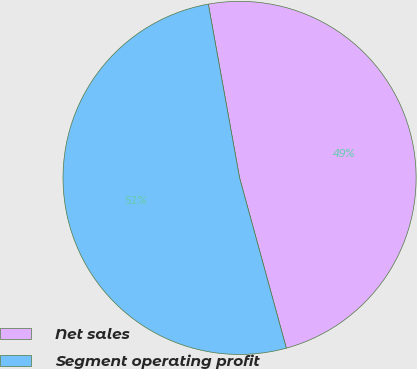<chart> <loc_0><loc_0><loc_500><loc_500><pie_chart><fcel>Net sales<fcel>Segment operating profit<nl><fcel>48.57%<fcel>51.43%<nl></chart> 